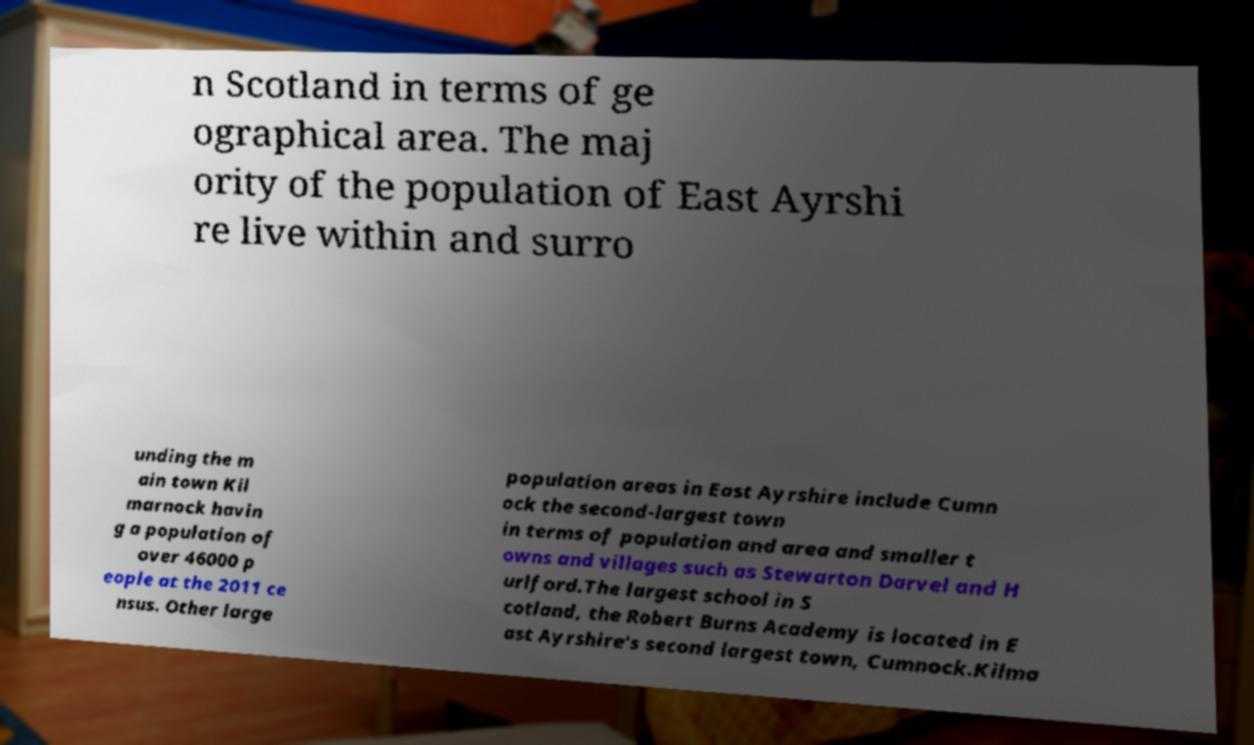There's text embedded in this image that I need extracted. Can you transcribe it verbatim? n Scotland in terms of ge ographical area. The maj ority of the population of East Ayrshi re live within and surro unding the m ain town Kil marnock havin g a population of over 46000 p eople at the 2011 ce nsus. Other large population areas in East Ayrshire include Cumn ock the second-largest town in terms of population and area and smaller t owns and villages such as Stewarton Darvel and H urlford.The largest school in S cotland, the Robert Burns Academy is located in E ast Ayrshire's second largest town, Cumnock.Kilma 